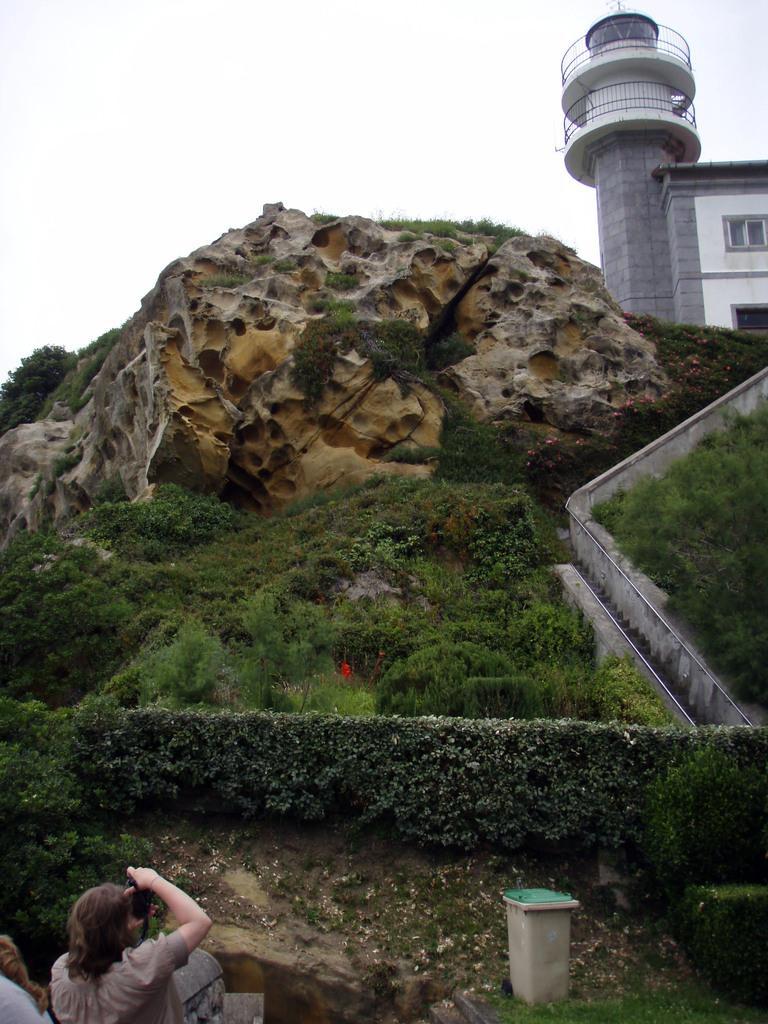Can you describe this image briefly? This picture is clicked outside. In the foreground we can see a person holding an object and we can see some other objects and we can see the grass, plants, stairway, railings and in the center we can see an object. In the background we can see the sky, tower and a building. 